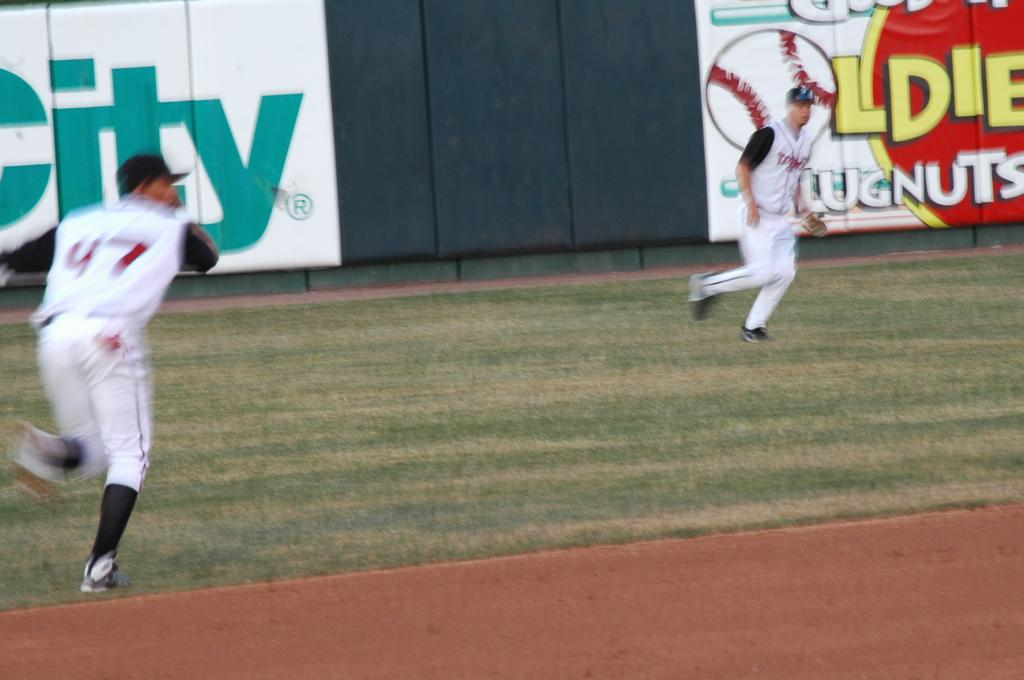<image>
Relay a brief, clear account of the picture shown. A baseball game with a O as a baseball on the wall. 